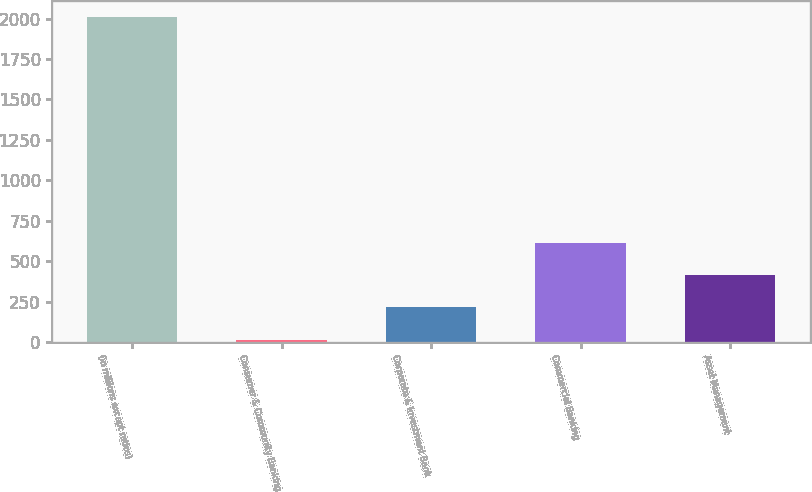Convert chart to OTSL. <chart><loc_0><loc_0><loc_500><loc_500><bar_chart><fcel>(in millions except ratios)<fcel>Consumer & Community Banking<fcel>Corporate & Investment Bank<fcel>Commercial Banking<fcel>Asset Management<nl><fcel>2011<fcel>15<fcel>214.6<fcel>613.8<fcel>414.2<nl></chart> 